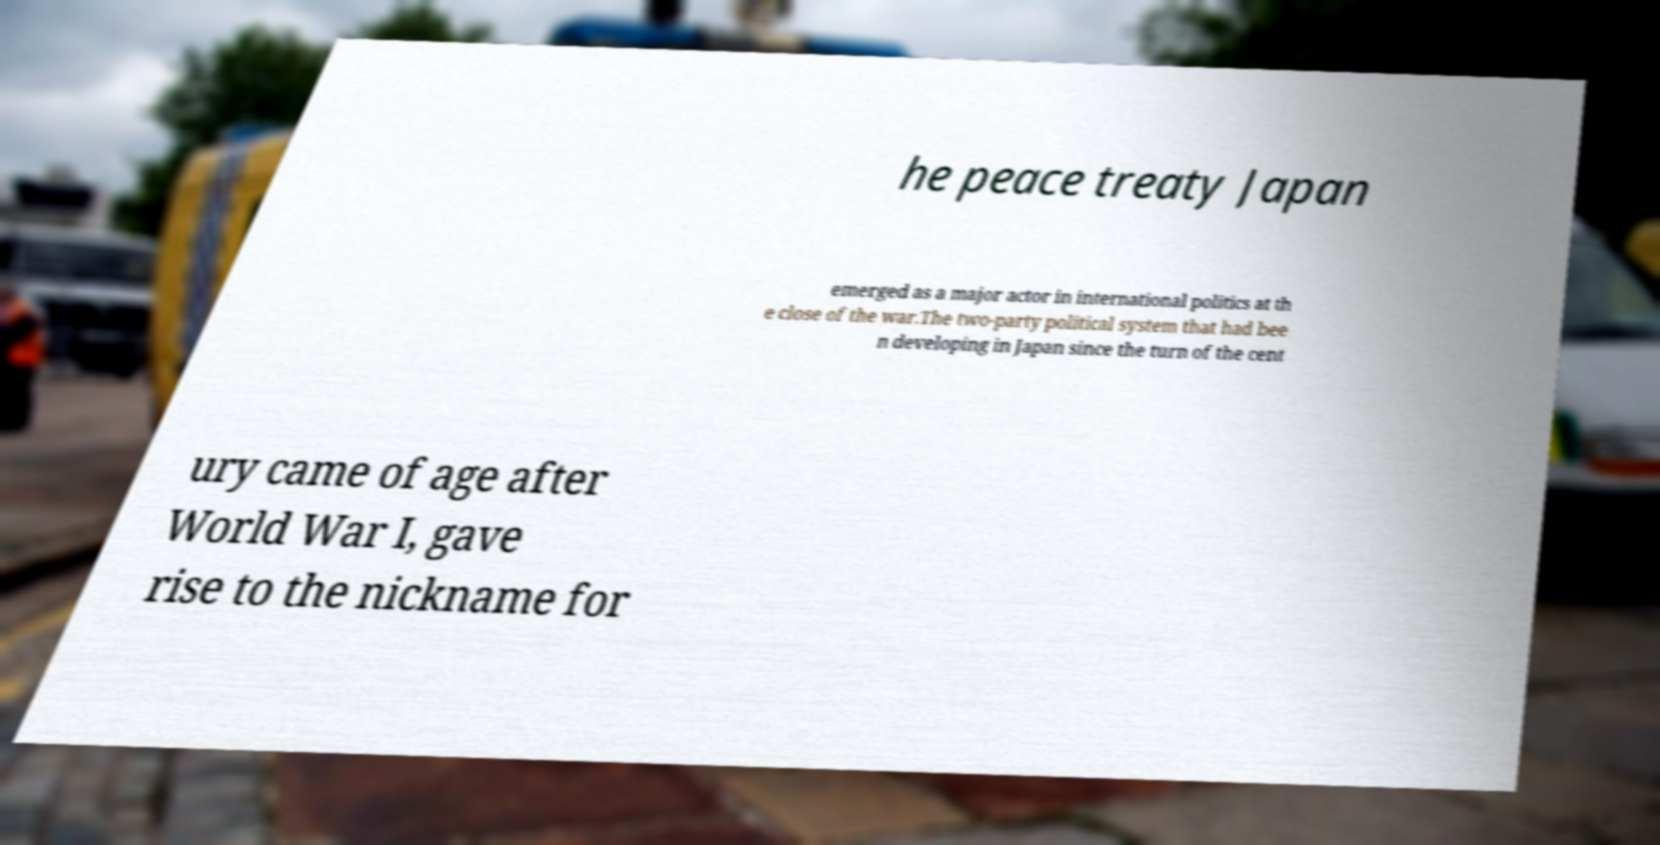Can you accurately transcribe the text from the provided image for me? he peace treaty Japan emerged as a major actor in international politics at th e close of the war.The two-party political system that had bee n developing in Japan since the turn of the cent ury came of age after World War I, gave rise to the nickname for 